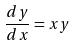<formula> <loc_0><loc_0><loc_500><loc_500>\frac { d y } { d x } = x y</formula> 